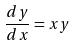<formula> <loc_0><loc_0><loc_500><loc_500>\frac { d y } { d x } = x y</formula> 